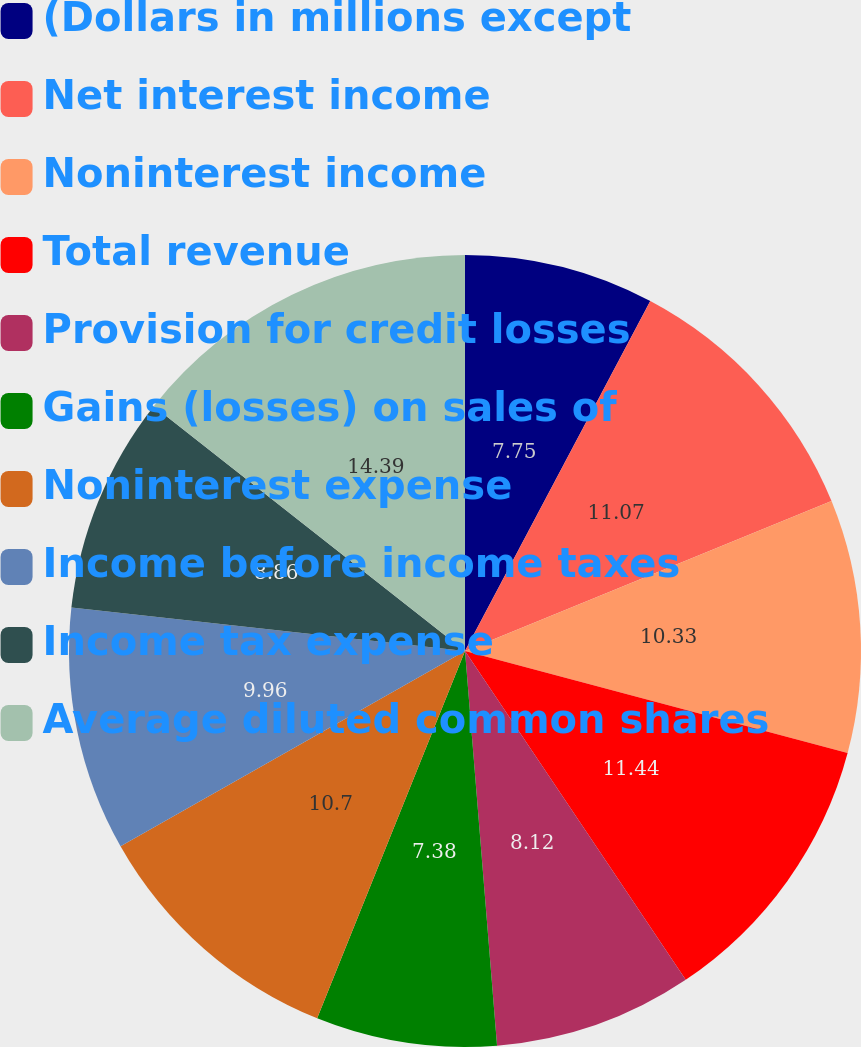<chart> <loc_0><loc_0><loc_500><loc_500><pie_chart><fcel>(Dollars in millions except<fcel>Net interest income<fcel>Noninterest income<fcel>Total revenue<fcel>Provision for credit losses<fcel>Gains (losses) on sales of<fcel>Noninterest expense<fcel>Income before income taxes<fcel>Income tax expense<fcel>Average diluted common shares<nl><fcel>7.75%<fcel>11.07%<fcel>10.33%<fcel>11.44%<fcel>8.12%<fcel>7.38%<fcel>10.7%<fcel>9.96%<fcel>8.86%<fcel>14.39%<nl></chart> 